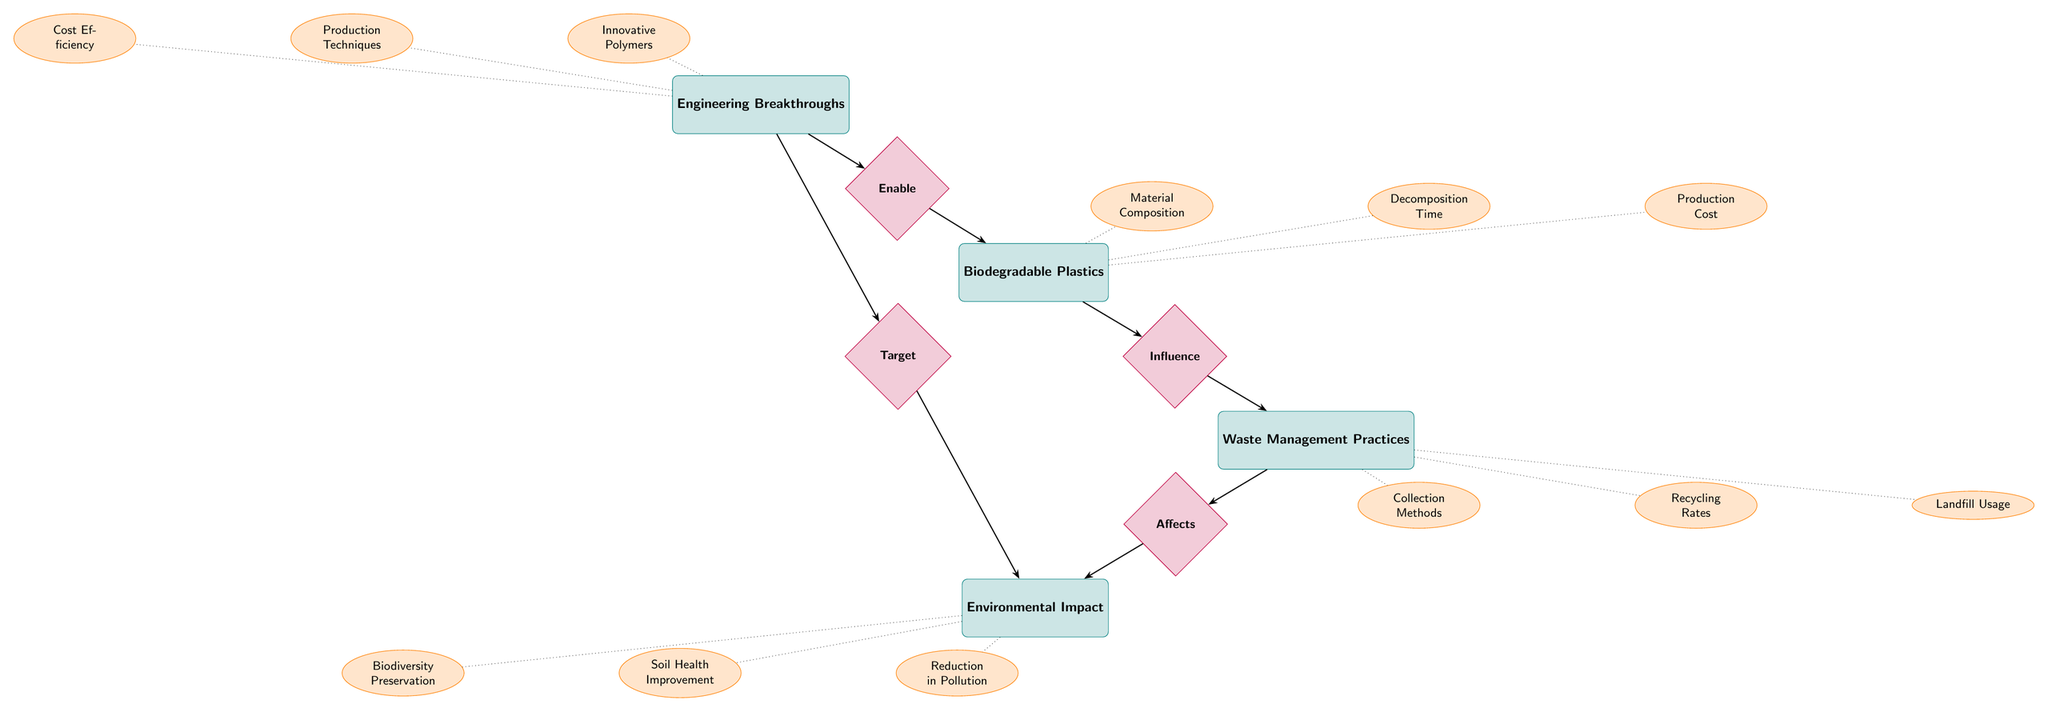What is the main entity related to "Waste Management Practices"? The main entity directly related to "Waste Management Practices" is "Biodegradable Plastics" as indicated by the "Influence" relationship connecting them.
Answer: Biodegradable Plastics How many attributes does "Environmental Impact" have? "Environmental Impact" has three attributes listed: "Reduction in Pollution," "Soil Health Improvement," and "Biodiversity Preservation." Therefore, the total is three.
Answer: 3 What relationship exists between "Waste Management Practices" and "Environmental Impact"? The relationship that connects "Waste Management Practices" to "Environmental Impact" is labeled "Affects," indicating a direct influence of waste management on the environment.
Answer: Affects Which entity influences "Biodegradable Plastics"? The entity that influences "Biodegradable Plastics" is "Engineering Breakthroughs," as shown by the "Enable" relationship leading from Engineering Breakthroughs to Biodegradable Plastics.
Answer: Engineering Breakthroughs What type of relationship connects "Engineering Breakthroughs" and "Environmental Impact"? The type of relationship that connects "Engineering Breakthroughs" and "Environmental Impact" is "Target," indicating a focus by breakthroughs on improving environmental outcomes.
Answer: Target What are the attributes of "Biodegradable Plastics"? The attributes of "Biodegradable Plastics" include: "Material Composition," "Decomposition Time," and "Production Cost." This information is visually represented as dotted connections stemming from the entity.
Answer: Material Composition, Decomposition Time, Production Cost What is the role of "Engineering Breakthroughs" in relation to "Biodegradable Plastics"? "Engineering Breakthroughs" have the role of enabling "Biodegradable Plastics" as indicated by the "Enable" relationship that connects these two entities in the diagram.
Answer: Enable 